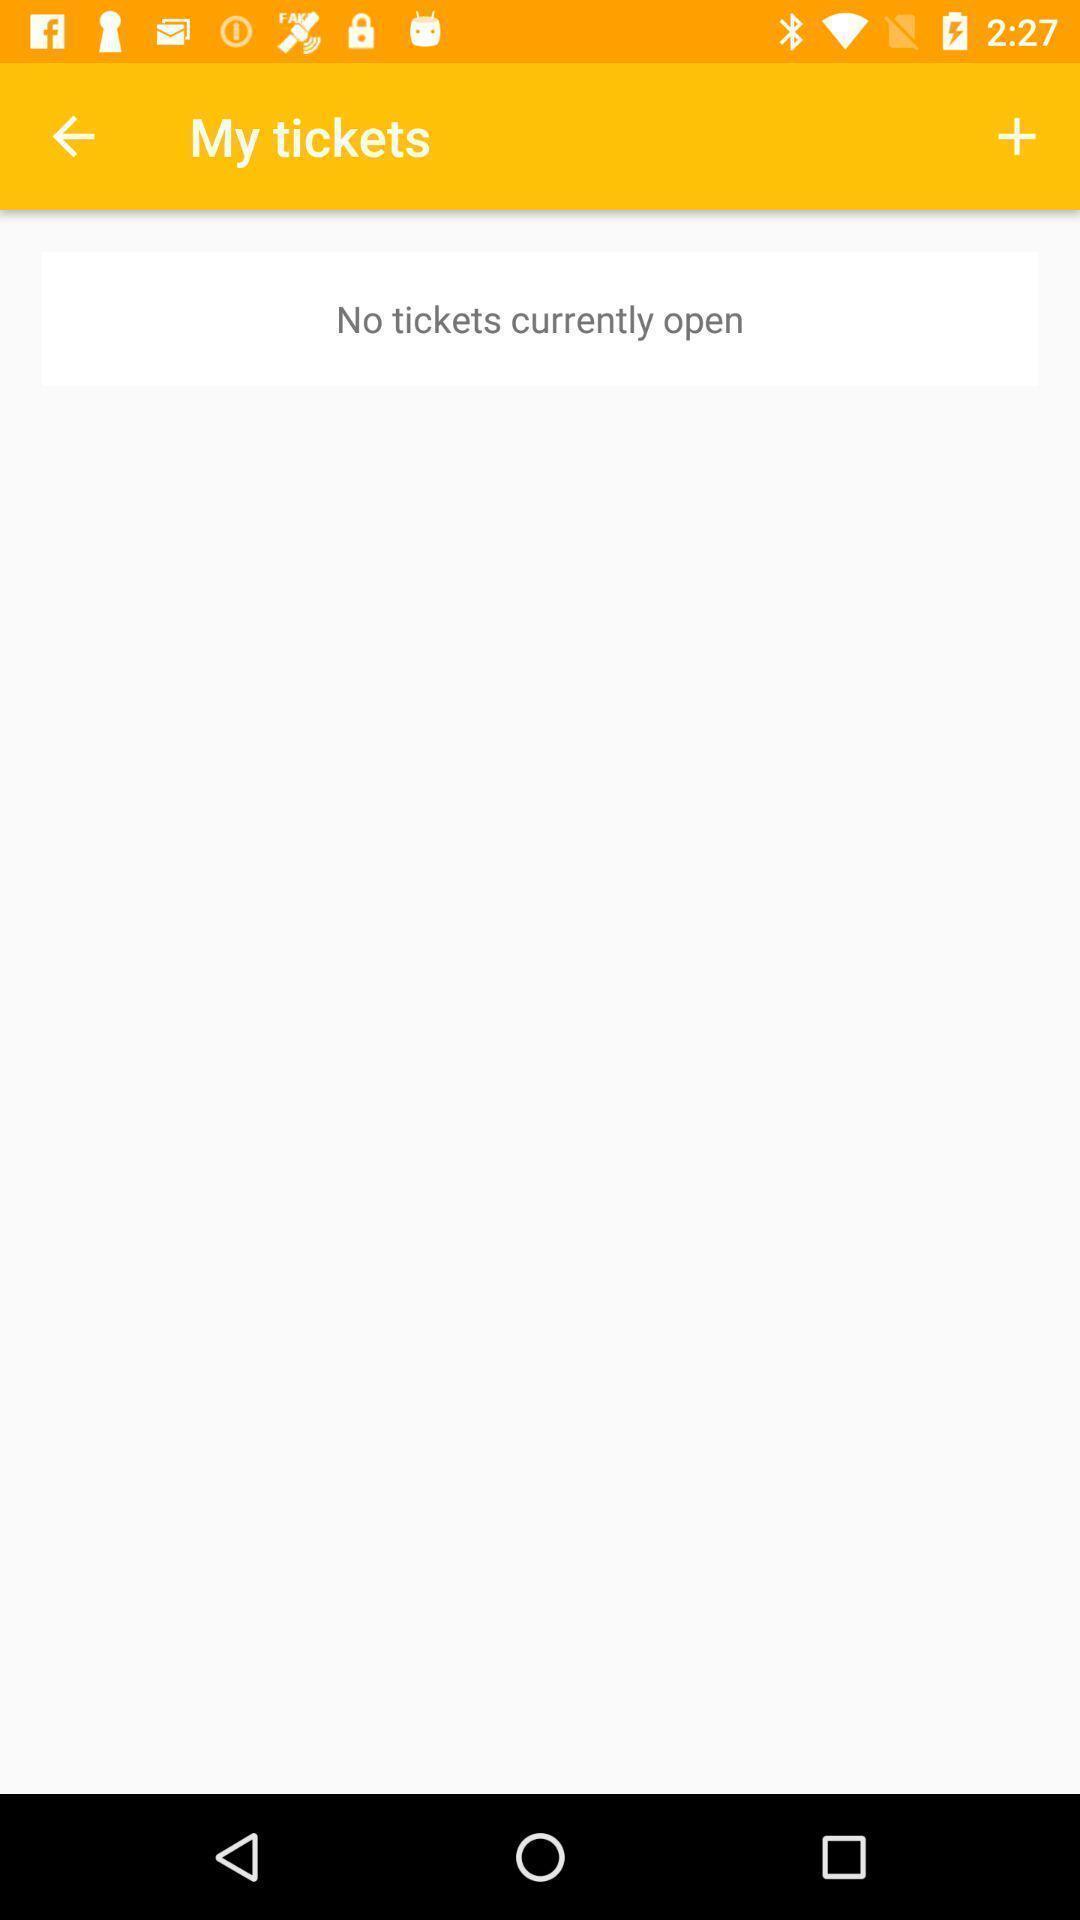Give me a summary of this screen capture. Page displaying options to book tickets. 